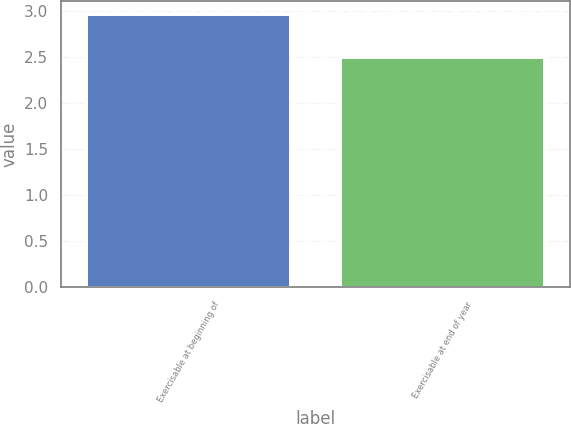Convert chart. <chart><loc_0><loc_0><loc_500><loc_500><bar_chart><fcel>Exercisable at beginning of<fcel>Exercisable at end of year<nl><fcel>2.96<fcel>2.49<nl></chart> 